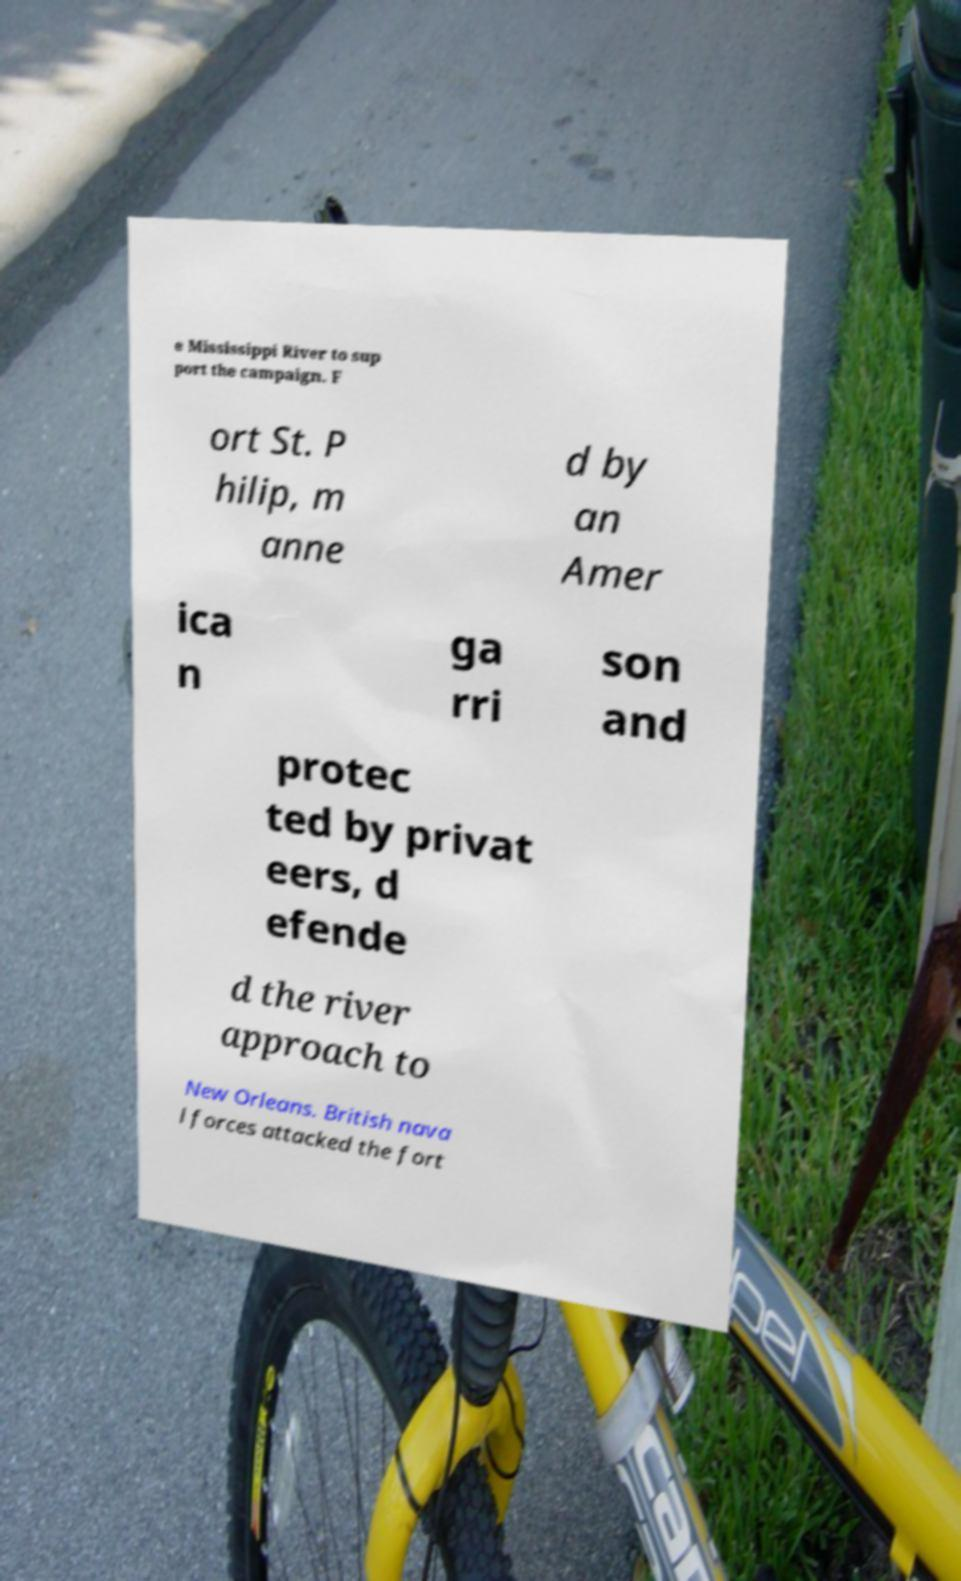There's text embedded in this image that I need extracted. Can you transcribe it verbatim? e Mississippi River to sup port the campaign. F ort St. P hilip, m anne d by an Amer ica n ga rri son and protec ted by privat eers, d efende d the river approach to New Orleans. British nava l forces attacked the fort 